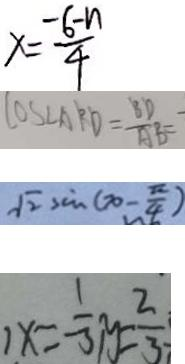<formula> <loc_0><loc_0><loc_500><loc_500>x = \frac { - 6 - n } { 4 } 
 \cos \angle A B D = \frac { B D } { A B } 
 \sqrt { 2 } \sin ( x - \frac { \pi } { 4 } ) 
 , x = - \frac { 1 } { 3 } , y = \frac { 2 } { 3 }</formula> 